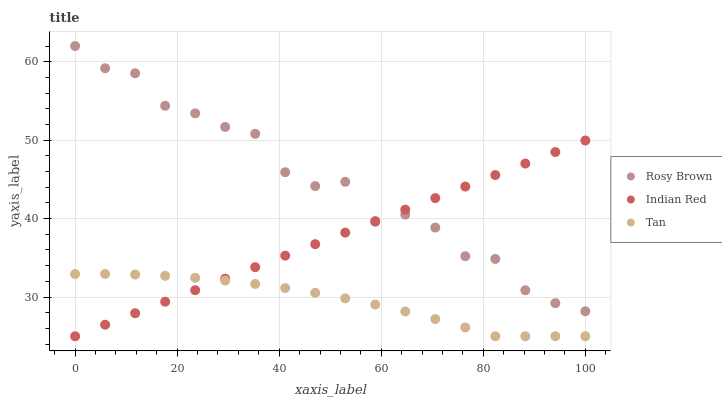Does Tan have the minimum area under the curve?
Answer yes or no. Yes. Does Rosy Brown have the maximum area under the curve?
Answer yes or no. Yes. Does Indian Red have the minimum area under the curve?
Answer yes or no. No. Does Indian Red have the maximum area under the curve?
Answer yes or no. No. Is Indian Red the smoothest?
Answer yes or no. Yes. Is Rosy Brown the roughest?
Answer yes or no. Yes. Is Rosy Brown the smoothest?
Answer yes or no. No. Is Indian Red the roughest?
Answer yes or no. No. Does Tan have the lowest value?
Answer yes or no. Yes. Does Rosy Brown have the lowest value?
Answer yes or no. No. Does Rosy Brown have the highest value?
Answer yes or no. Yes. Does Indian Red have the highest value?
Answer yes or no. No. Is Tan less than Rosy Brown?
Answer yes or no. Yes. Is Rosy Brown greater than Tan?
Answer yes or no. Yes. Does Rosy Brown intersect Indian Red?
Answer yes or no. Yes. Is Rosy Brown less than Indian Red?
Answer yes or no. No. Is Rosy Brown greater than Indian Red?
Answer yes or no. No. Does Tan intersect Rosy Brown?
Answer yes or no. No. 